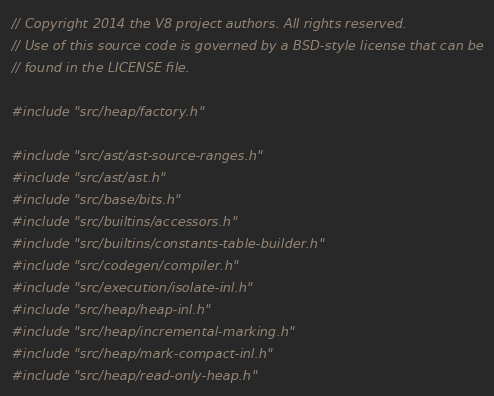<code> <loc_0><loc_0><loc_500><loc_500><_C++_>// Copyright 2014 the V8 project authors. All rights reserved.
// Use of this source code is governed by a BSD-style license that can be
// found in the LICENSE file.

#include "src/heap/factory.h"

#include "src/ast/ast-source-ranges.h"
#include "src/ast/ast.h"
#include "src/base/bits.h"
#include "src/builtins/accessors.h"
#include "src/builtins/constants-table-builder.h"
#include "src/codegen/compiler.h"
#include "src/execution/isolate-inl.h"
#include "src/heap/heap-inl.h"
#include "src/heap/incremental-marking.h"
#include "src/heap/mark-compact-inl.h"
#include "src/heap/read-only-heap.h"</code> 